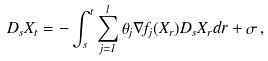<formula> <loc_0><loc_0><loc_500><loc_500>D _ { s } X _ { t } = - \int _ { s } ^ { t } \sum _ { j = 1 } ^ { l } \theta _ { j } \nabla f _ { j } ( X _ { r } ) D _ { s } X _ { r } d r + \sigma \, ,</formula> 